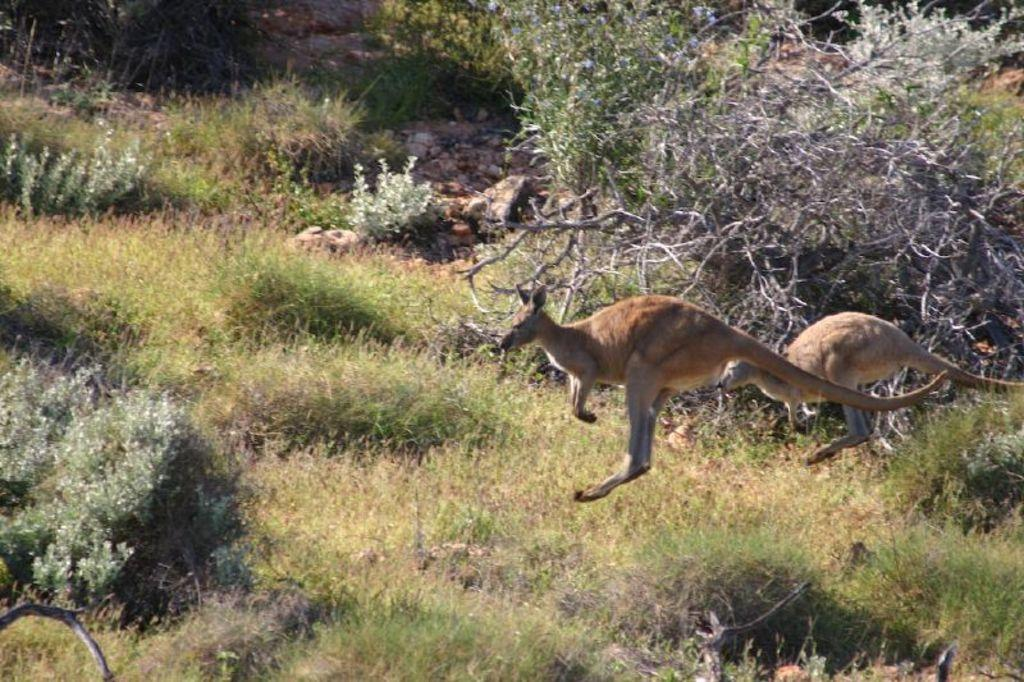What type of animals are in the image? There are kangaroos in the image. What can be seen in the background of the image? There are trees in the image. What is present on the ground in the image? There are plants on the ground in the image. What type of screw can be seen in the image? There is no screw present in the image; it features kangaroos, trees, and plants on the ground. What type of school can be seen in the image? There is no school present in the image; it features kangaroos, trees, and plants on the ground. 